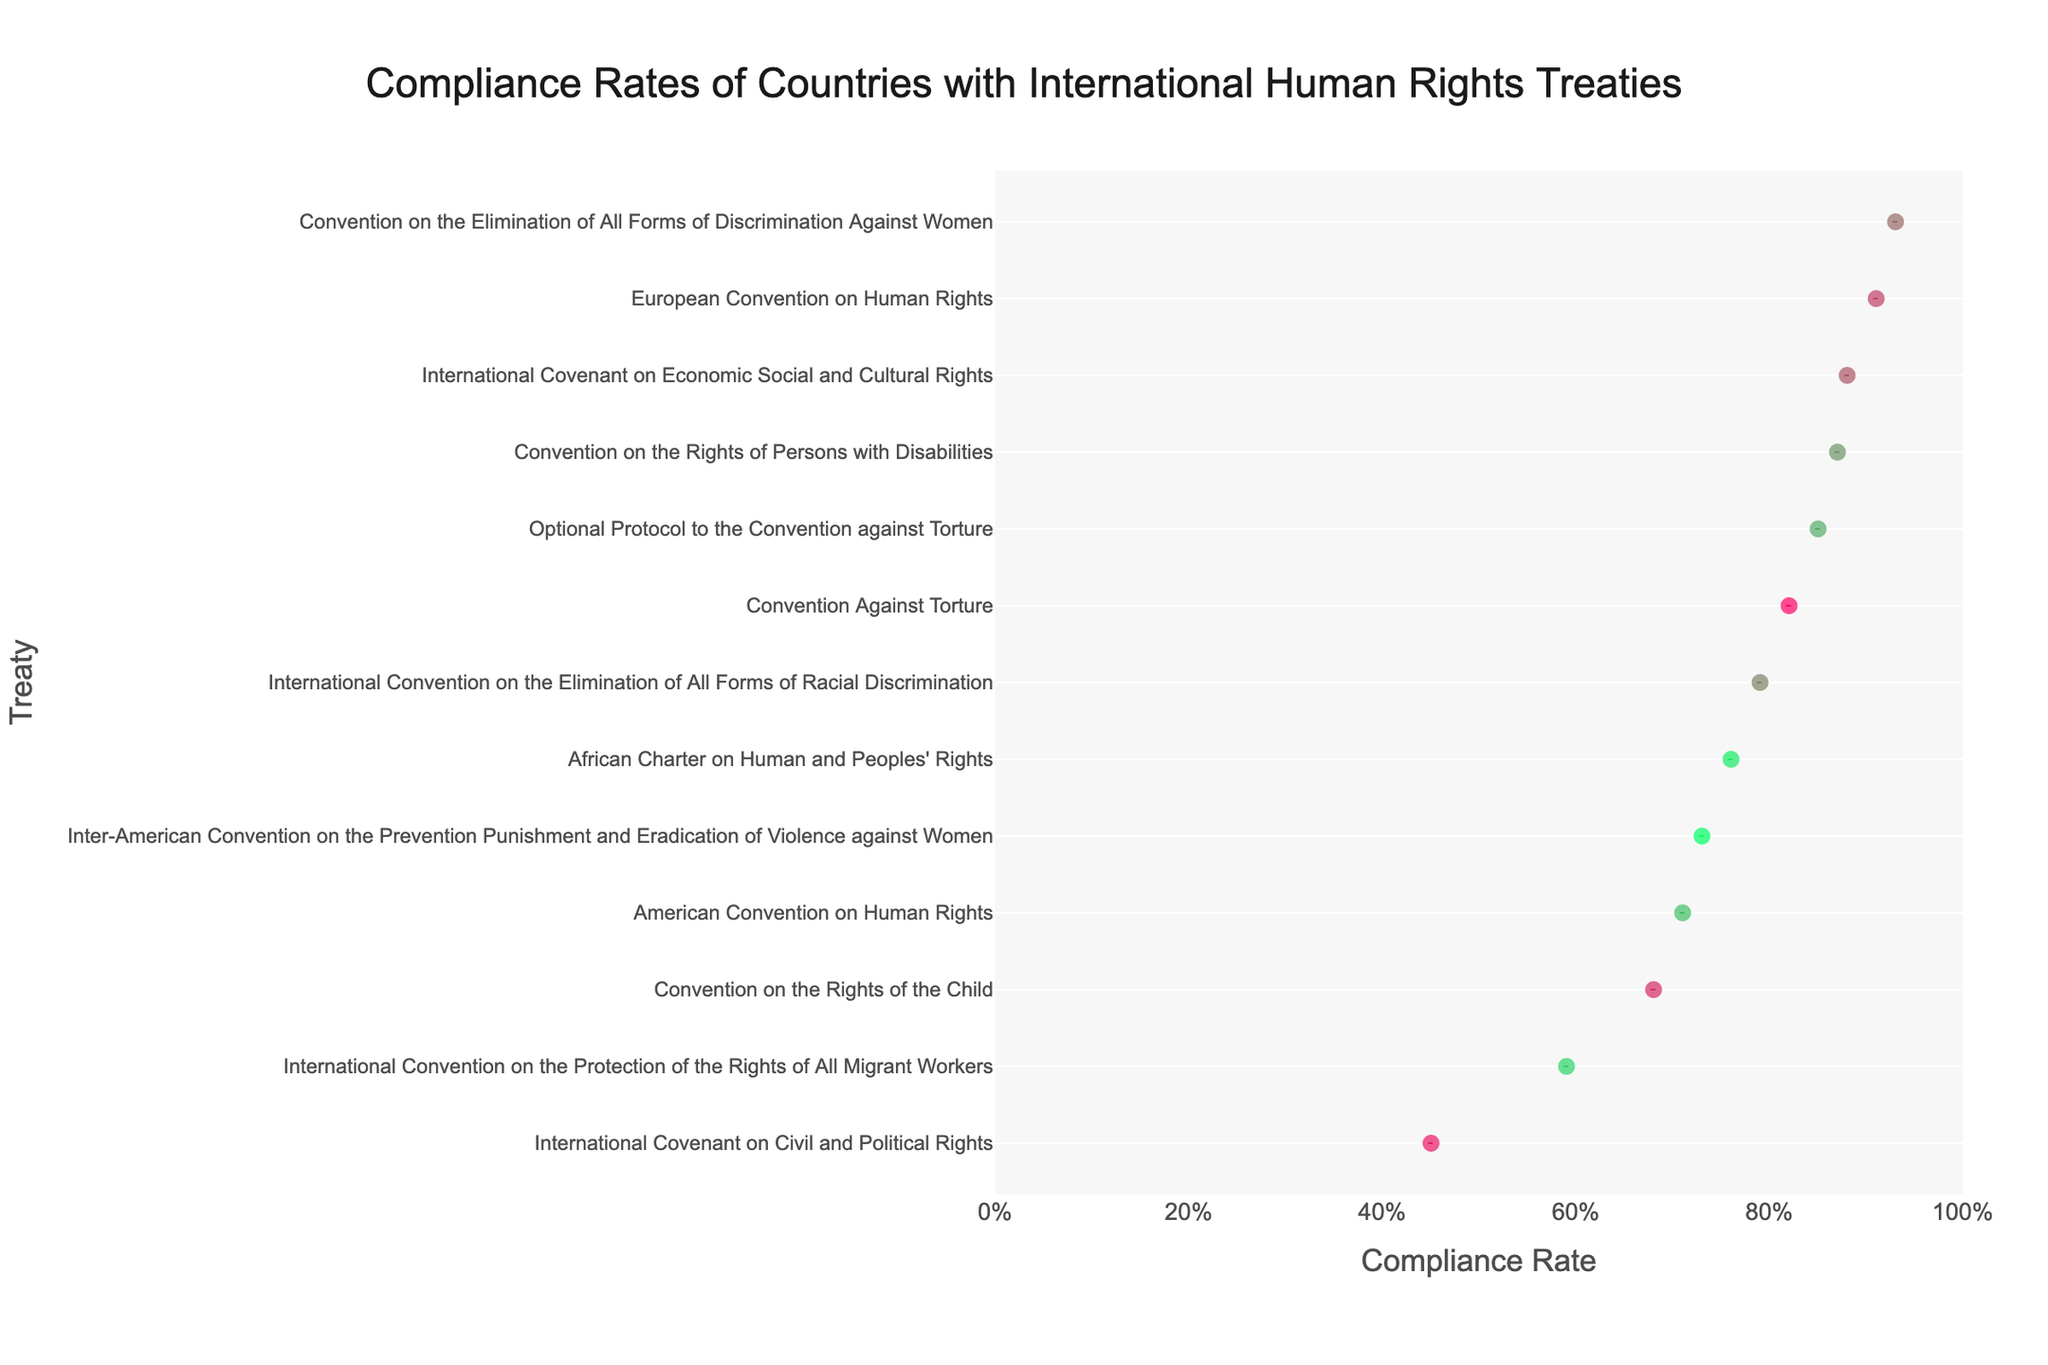What is the title of the strip plot? The title of a plot is typically found at the top and is used to provide an overview or context of what the plot represents. Here, it's written in large text at the top center.
Answer: Compliance Rates of Countries with International Human Rights Treaties Which country has the highest compliance rate? The strip plot will display each country's compliance rate along a continuum, making it straightforward to identify the one with the highest rate.
Answer: Germany Which treaty has the lowest compliance rate? To determine the treaty with the lowest compliance rate, look for the point that is closest to zero on the x-axis.
Answer: International Covenant on Civil and Political Rights (China) What is the range of compliance rates shown in the plot? The range can be found by identifying the minimum and maximum points on the x-axis. The minimum is 0.45 (China) and the maximum is 0.93 (Germany).
Answer: 0.45 to 0.93 Which treaty has the most variable compliance rates among countries? Variability can be determined by observing the spread of data points. The treaty with the widest spread between its points indicates the most variability.
Answer: International Covenant on Civil and Political Rights How many countries have a compliance rate above 0.80? Count all the data points that lie to the right of 0.80 on the x-axis.
Answer: 6 Does the United Kingdom have a higher compliance rate than Japan? Directly compare the positions of the points for the United Kingdom and Japan on the x-axis. The position further to the right has the higher compliance rate.
Answer: Yes What is the average compliance rate for the treaties shown? Calculate the mean of all the compliance rates by summing them up and dividing by the number of treaties. Sum: 0.82 + 0.45 + 0.68 + 0.91 + 0.88 + 0.93 + 0.79 + 0.87 + 0.85 + 0.71 + 0.59 + 0.76 + 0.73 = 9.97. Number of treaties = 13. Average = 9.97/13.
Answer: 0.77 Which treaty shows compliance from more than one country? Identify treaties where more than one data point is plotted in their line on the plot. Since this is a strip plot with specified data, each treaty is distinct to one country only in this data set.
Answer: None 